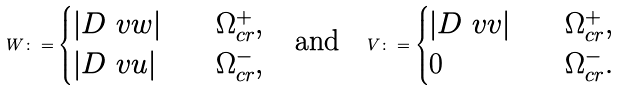Convert formula to latex. <formula><loc_0><loc_0><loc_500><loc_500>W \colon = \begin{cases} | D \ v w | \quad & \Omega _ { c r } ^ { + } , \\ | D \ v u | \quad & \Omega _ { c r } ^ { - } , \end{cases} \quad \text {and} \quad V \colon = \begin{cases} | D \ v v | \quad & \Omega _ { c r } ^ { + } , \\ 0 \quad & \Omega _ { c r } ^ { - } . \end{cases}</formula> 